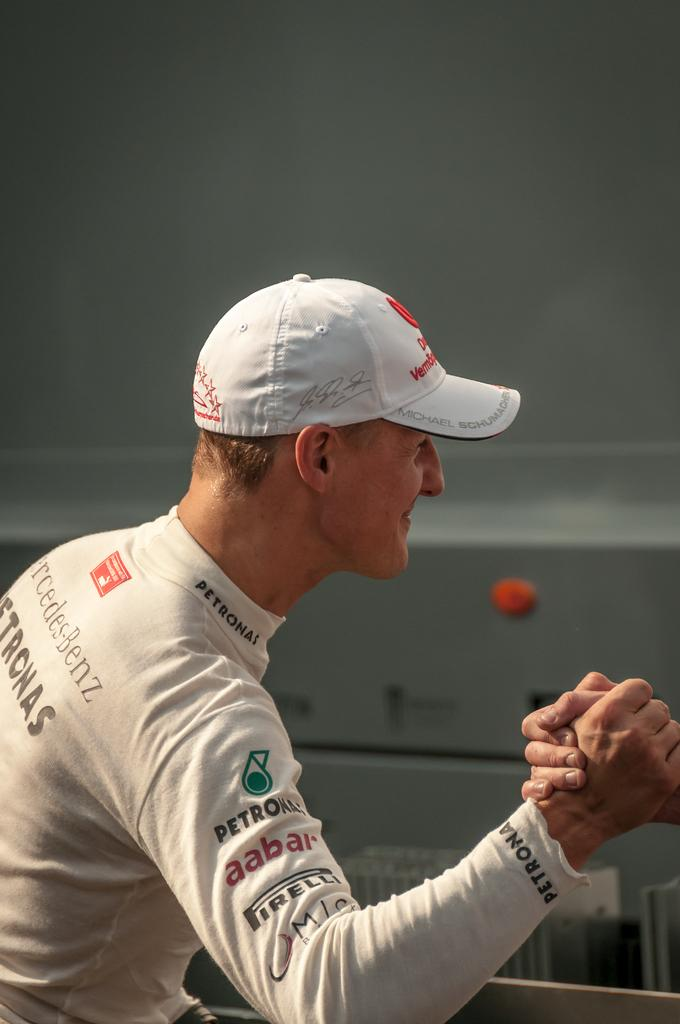What is the man in the image doing with his hand? The man is holding the hand of another person in the image. What can be seen in the background of the image? There is a wall in the background of the image. What is visible at the top of the image? There is a roof visible at the top of the image. What type of cup is the chicken holding in the image? There is no cup or chicken present in the image. What type of education is being discussed in the image? There is no discussion of education in the image. 